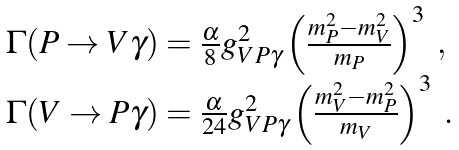Convert formula to latex. <formula><loc_0><loc_0><loc_500><loc_500>\begin{array} { l } { { \Gamma ( P \rightarrow V \gamma ) = \frac { \alpha } { 8 } g _ { V P \gamma } ^ { 2 } \left ( \frac { m _ { P } ^ { 2 } - m _ { V } ^ { 2 } } { m _ { P } } \right ) ^ { 3 } \ , } } \\ { { \Gamma ( V \rightarrow P \gamma ) = \frac { \alpha } { 2 4 } g _ { V P \gamma } ^ { 2 } \left ( \frac { m _ { V } ^ { 2 } - m _ { P } ^ { 2 } } { m _ { V } } \right ) ^ { 3 } \ . } } \end{array}</formula> 